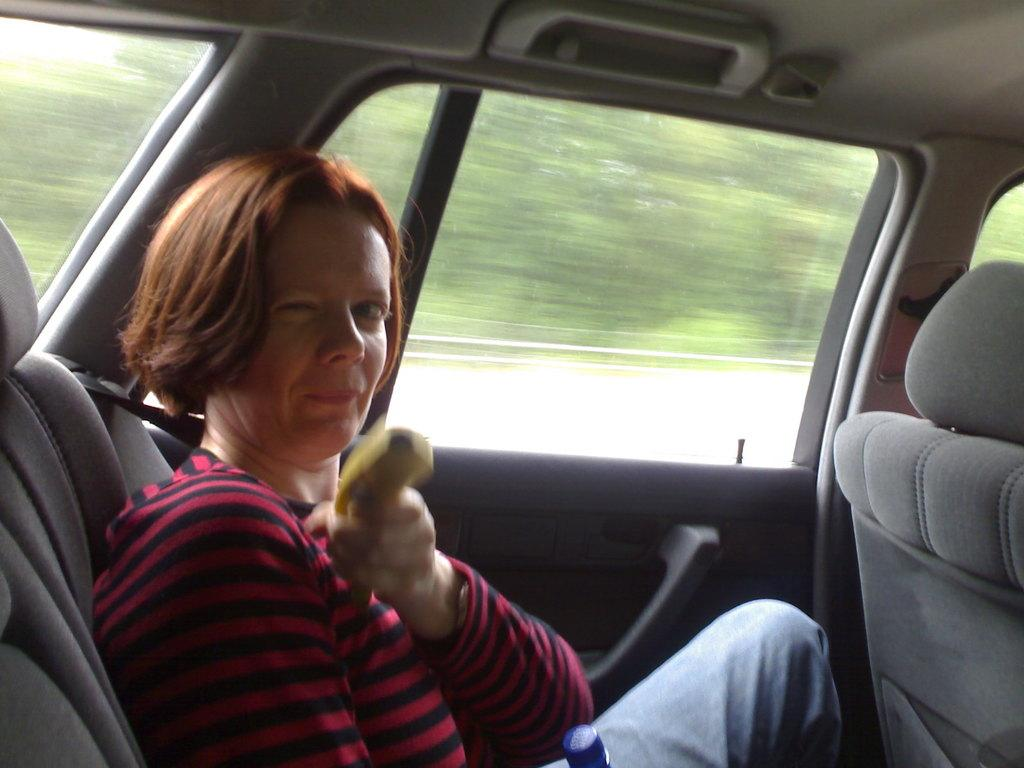Who is present in the image? There is a woman in the image. What is the woman doing in the image? The woman is sitting in a car. What type of creature can be seen sitting next to the woman in the image? There is no creature present in the image; only the woman is visible. What border is depicted in the image? There is no border present in the image; it features a woman sitting in a car. 